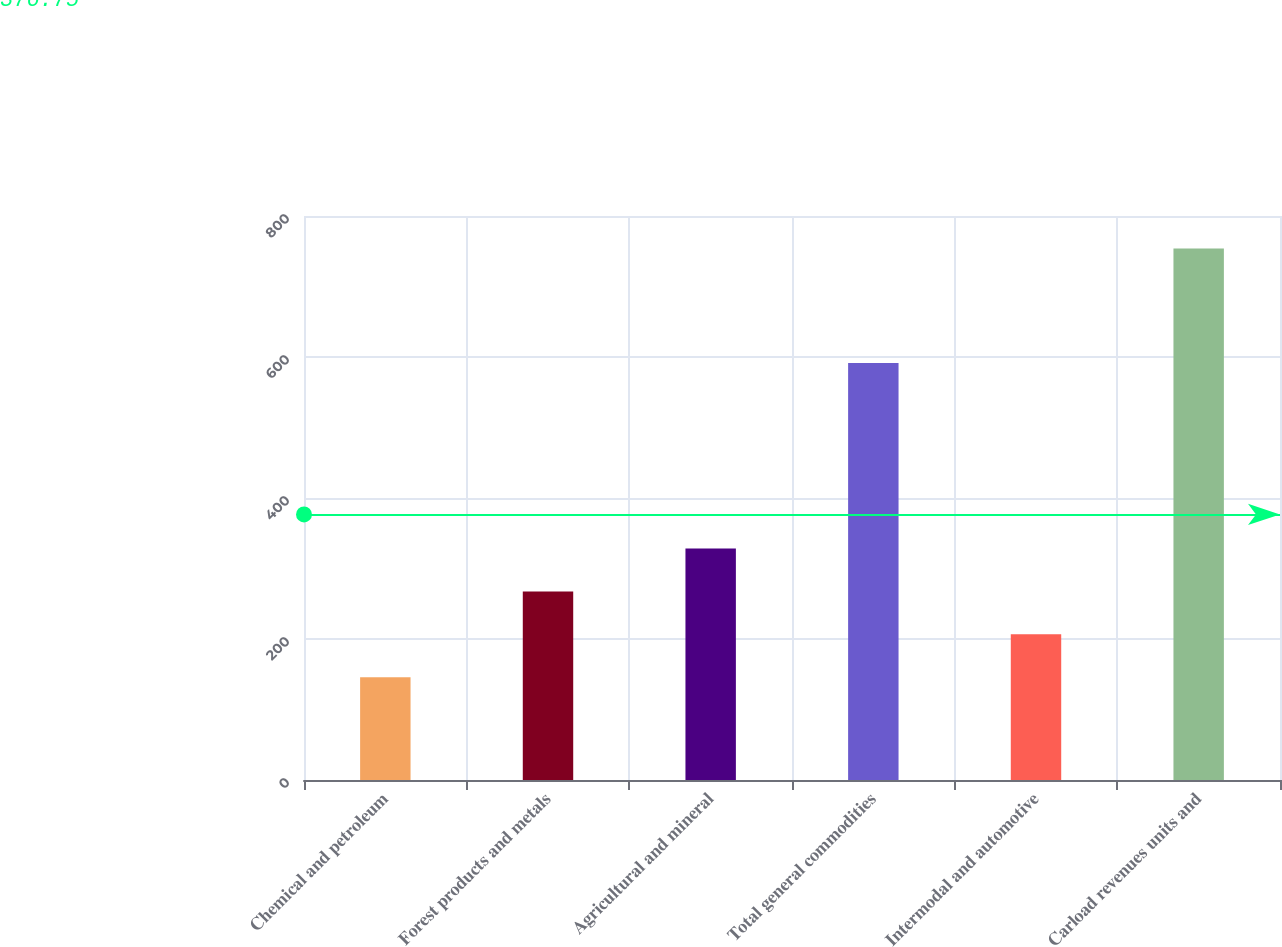<chart> <loc_0><loc_0><loc_500><loc_500><bar_chart><fcel>Chemical and petroleum<fcel>Forest products and metals<fcel>Agricultural and mineral<fcel>Total general commodities<fcel>Intermodal and automotive<fcel>Carload revenues units and<nl><fcel>145.9<fcel>267.52<fcel>328.33<fcel>591.6<fcel>206.71<fcel>754<nl></chart> 